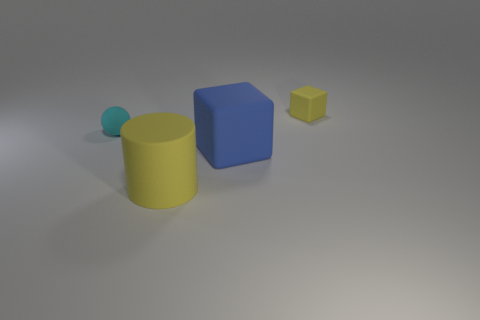Add 4 tiny cyan spheres. How many objects exist? 8 Subtract all balls. How many objects are left? 3 Subtract 0 gray spheres. How many objects are left? 4 Subtract all small yellow shiny balls. Subtract all yellow matte objects. How many objects are left? 2 Add 3 balls. How many balls are left? 4 Add 3 big yellow rubber objects. How many big yellow rubber objects exist? 4 